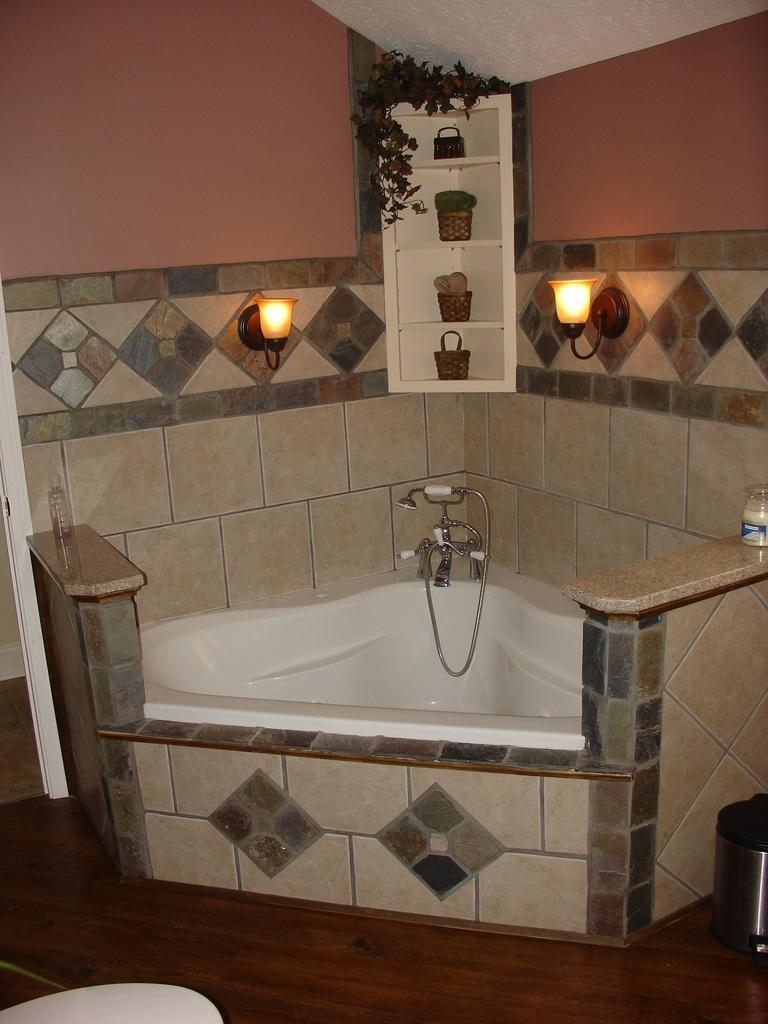What is the primary object in the image related to water? There is a water tap in the image. What is the water tap connected to in the image? The water tap is connected to a bathtub in the image. What can be seen providing illumination in the image? There are lights in the image. What type of storage containers are present in the image? There are baskets and a jar in the image. What living organism is present in the image? There is a plant in the image. What is a receptacle for holding water visible in the image? There is a water bottle in the image. What is a receptacle for holding waste visible in the image? There is a dustbin in the image. How many apples are hanging from the plant in the image? There are no apples present in the image; the plant is not specified as an apple tree or any other fruit-bearing plant. 